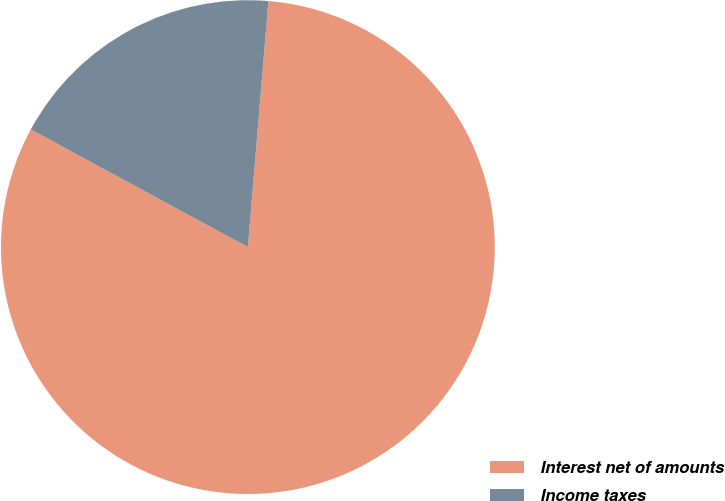Convert chart to OTSL. <chart><loc_0><loc_0><loc_500><loc_500><pie_chart><fcel>Interest net of amounts<fcel>Income taxes<nl><fcel>81.58%<fcel>18.42%<nl></chart> 